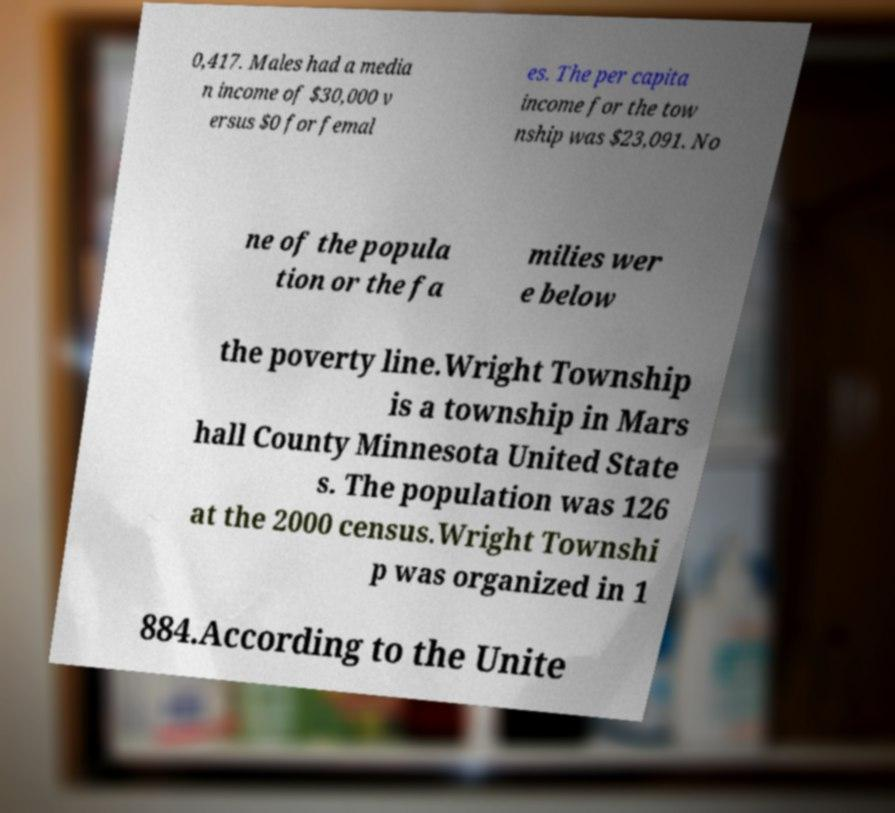Can you accurately transcribe the text from the provided image for me? 0,417. Males had a media n income of $30,000 v ersus $0 for femal es. The per capita income for the tow nship was $23,091. No ne of the popula tion or the fa milies wer e below the poverty line.Wright Township is a township in Mars hall County Minnesota United State s. The population was 126 at the 2000 census.Wright Townshi p was organized in 1 884.According to the Unite 